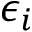Convert formula to latex. <formula><loc_0><loc_0><loc_500><loc_500>\epsilon _ { i }</formula> 